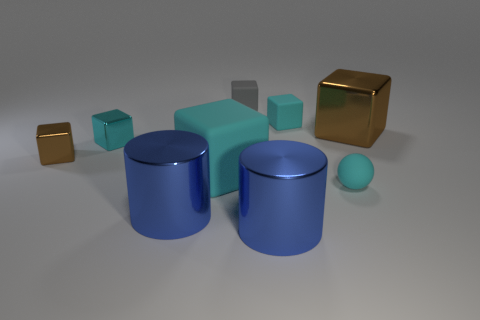There is another big cyan object that is the same shape as the cyan shiny object; what material is it?
Ensure brevity in your answer.  Rubber. What number of matte objects are either big blue cylinders or green cubes?
Your answer should be very brief. 0. How many other tiny metal things have the same shape as the small brown metallic thing?
Provide a succinct answer. 1. Is the shape of the small rubber object that is in front of the cyan metal cube the same as the blue shiny object to the left of the large cyan matte cube?
Ensure brevity in your answer.  No. How many things are either cyan metal balls or cubes in front of the small brown shiny cube?
Give a very brief answer. 1. What shape is the metal thing that is the same color as the big shiny cube?
Your answer should be compact. Cube. How many blue metallic objects have the same size as the cyan metal cube?
Give a very brief answer. 0. What number of blue objects are large objects or matte cubes?
Your response must be concise. 2. There is a small cyan rubber object that is in front of the large thing behind the small brown object; what is its shape?
Keep it short and to the point. Sphere. Is there a big block of the same color as the small ball?
Offer a very short reply. Yes. 